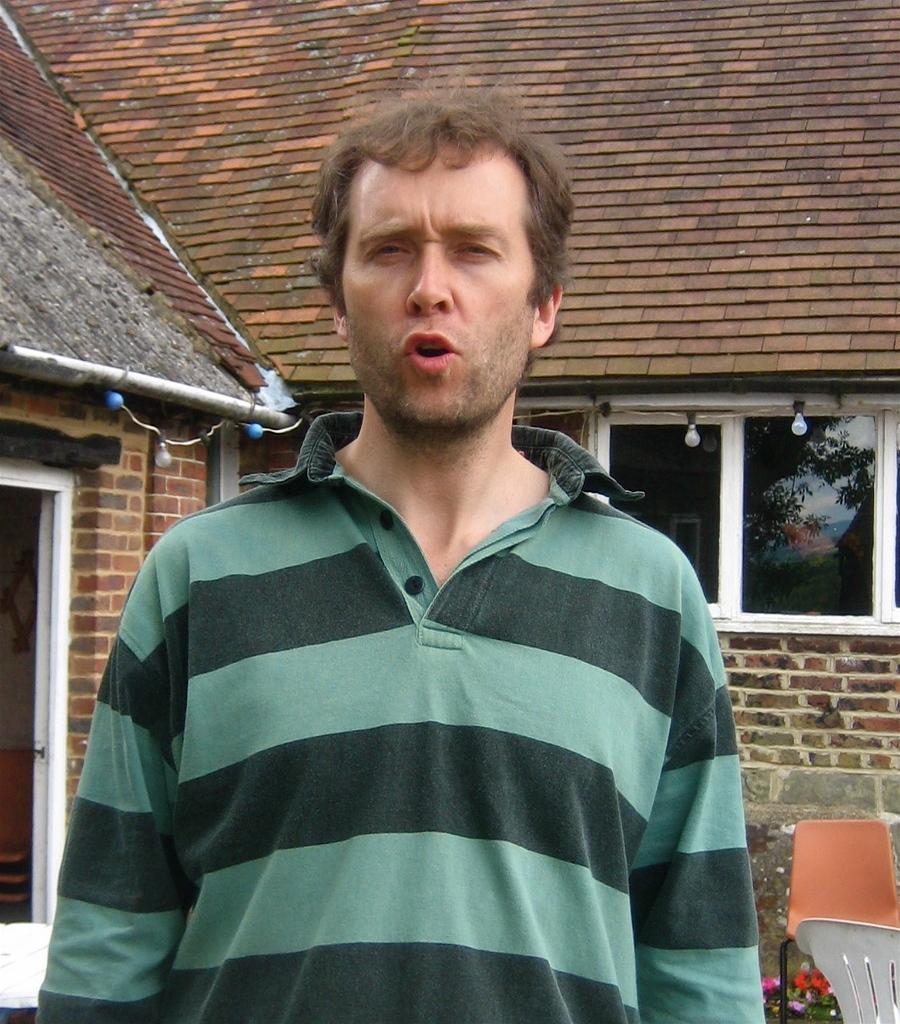Who is in the image? There is a man in the image. What is behind the man? There are chairs visible behind the man. What type of plants can be seen in the image? Flowers are present in the image. What can be seen illuminating the scene? Lights are visible in the image. What type of building is in the background of the image? There is a house in the background of the image. What type of animal is the man holding in the image? There is no animal present in the image. How many cubs can be seen playing with the man in the image? There are no cubs present in the image. 